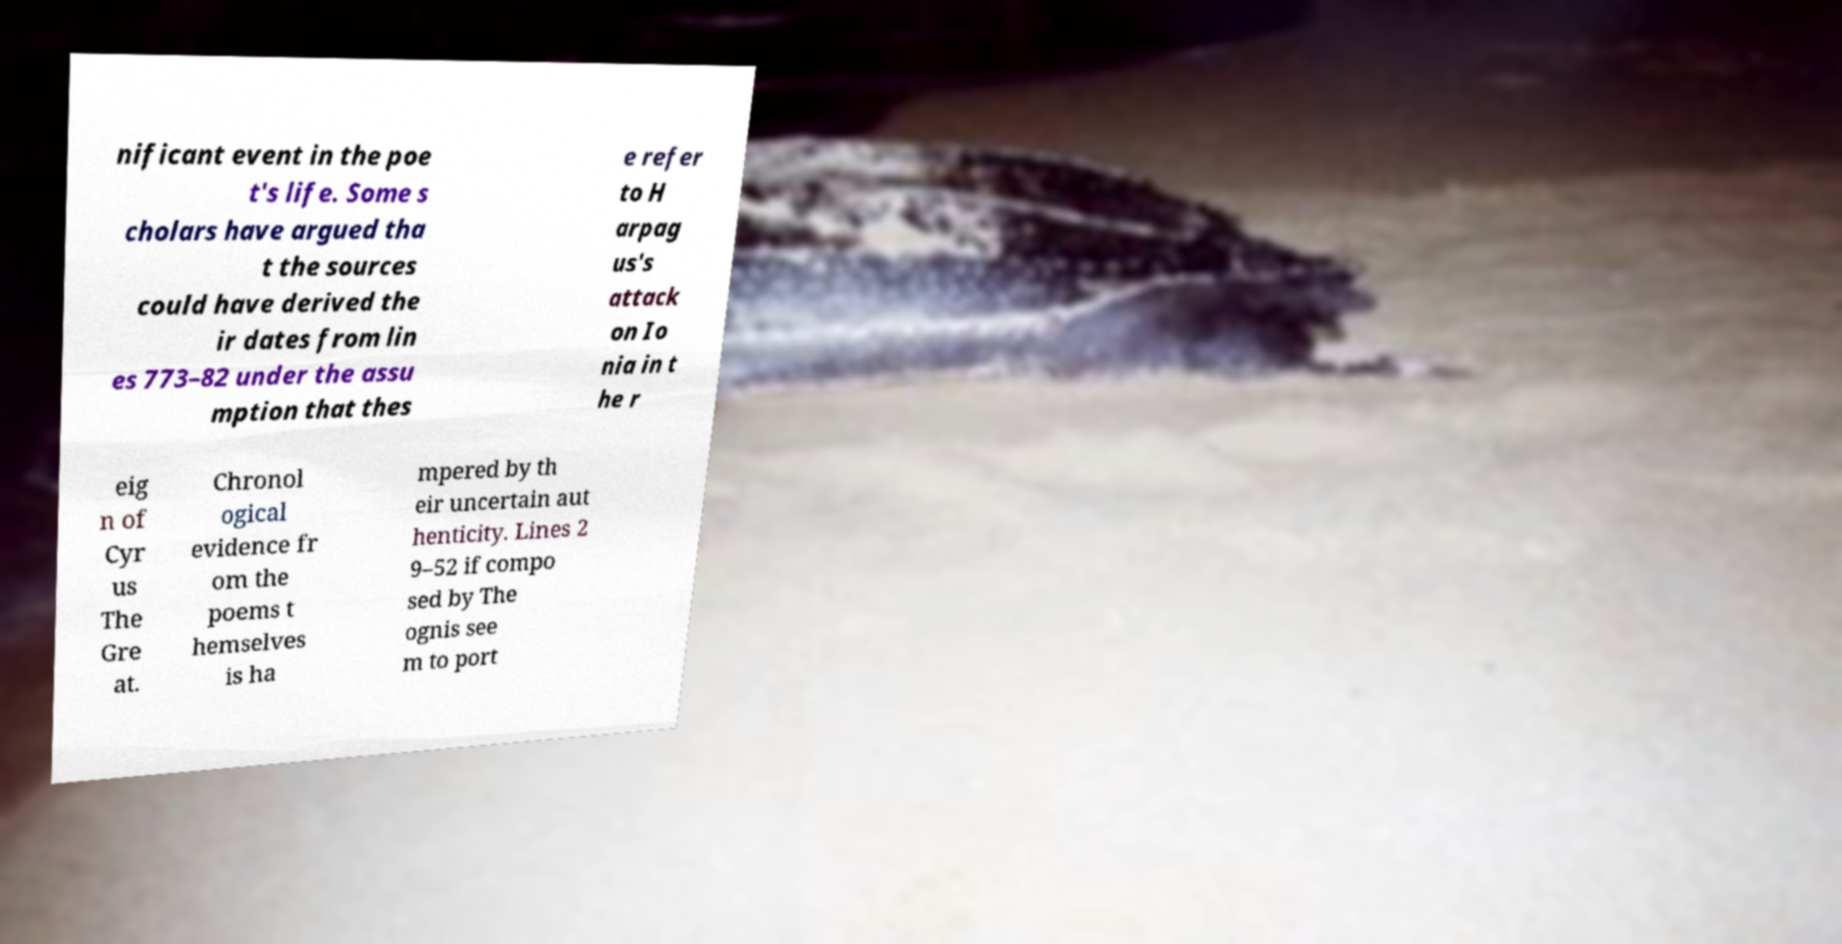I need the written content from this picture converted into text. Can you do that? nificant event in the poe t's life. Some s cholars have argued tha t the sources could have derived the ir dates from lin es 773–82 under the assu mption that thes e refer to H arpag us's attack on Io nia in t he r eig n of Cyr us The Gre at. Chronol ogical evidence fr om the poems t hemselves is ha mpered by th eir uncertain aut henticity. Lines 2 9–52 if compo sed by The ognis see m to port 